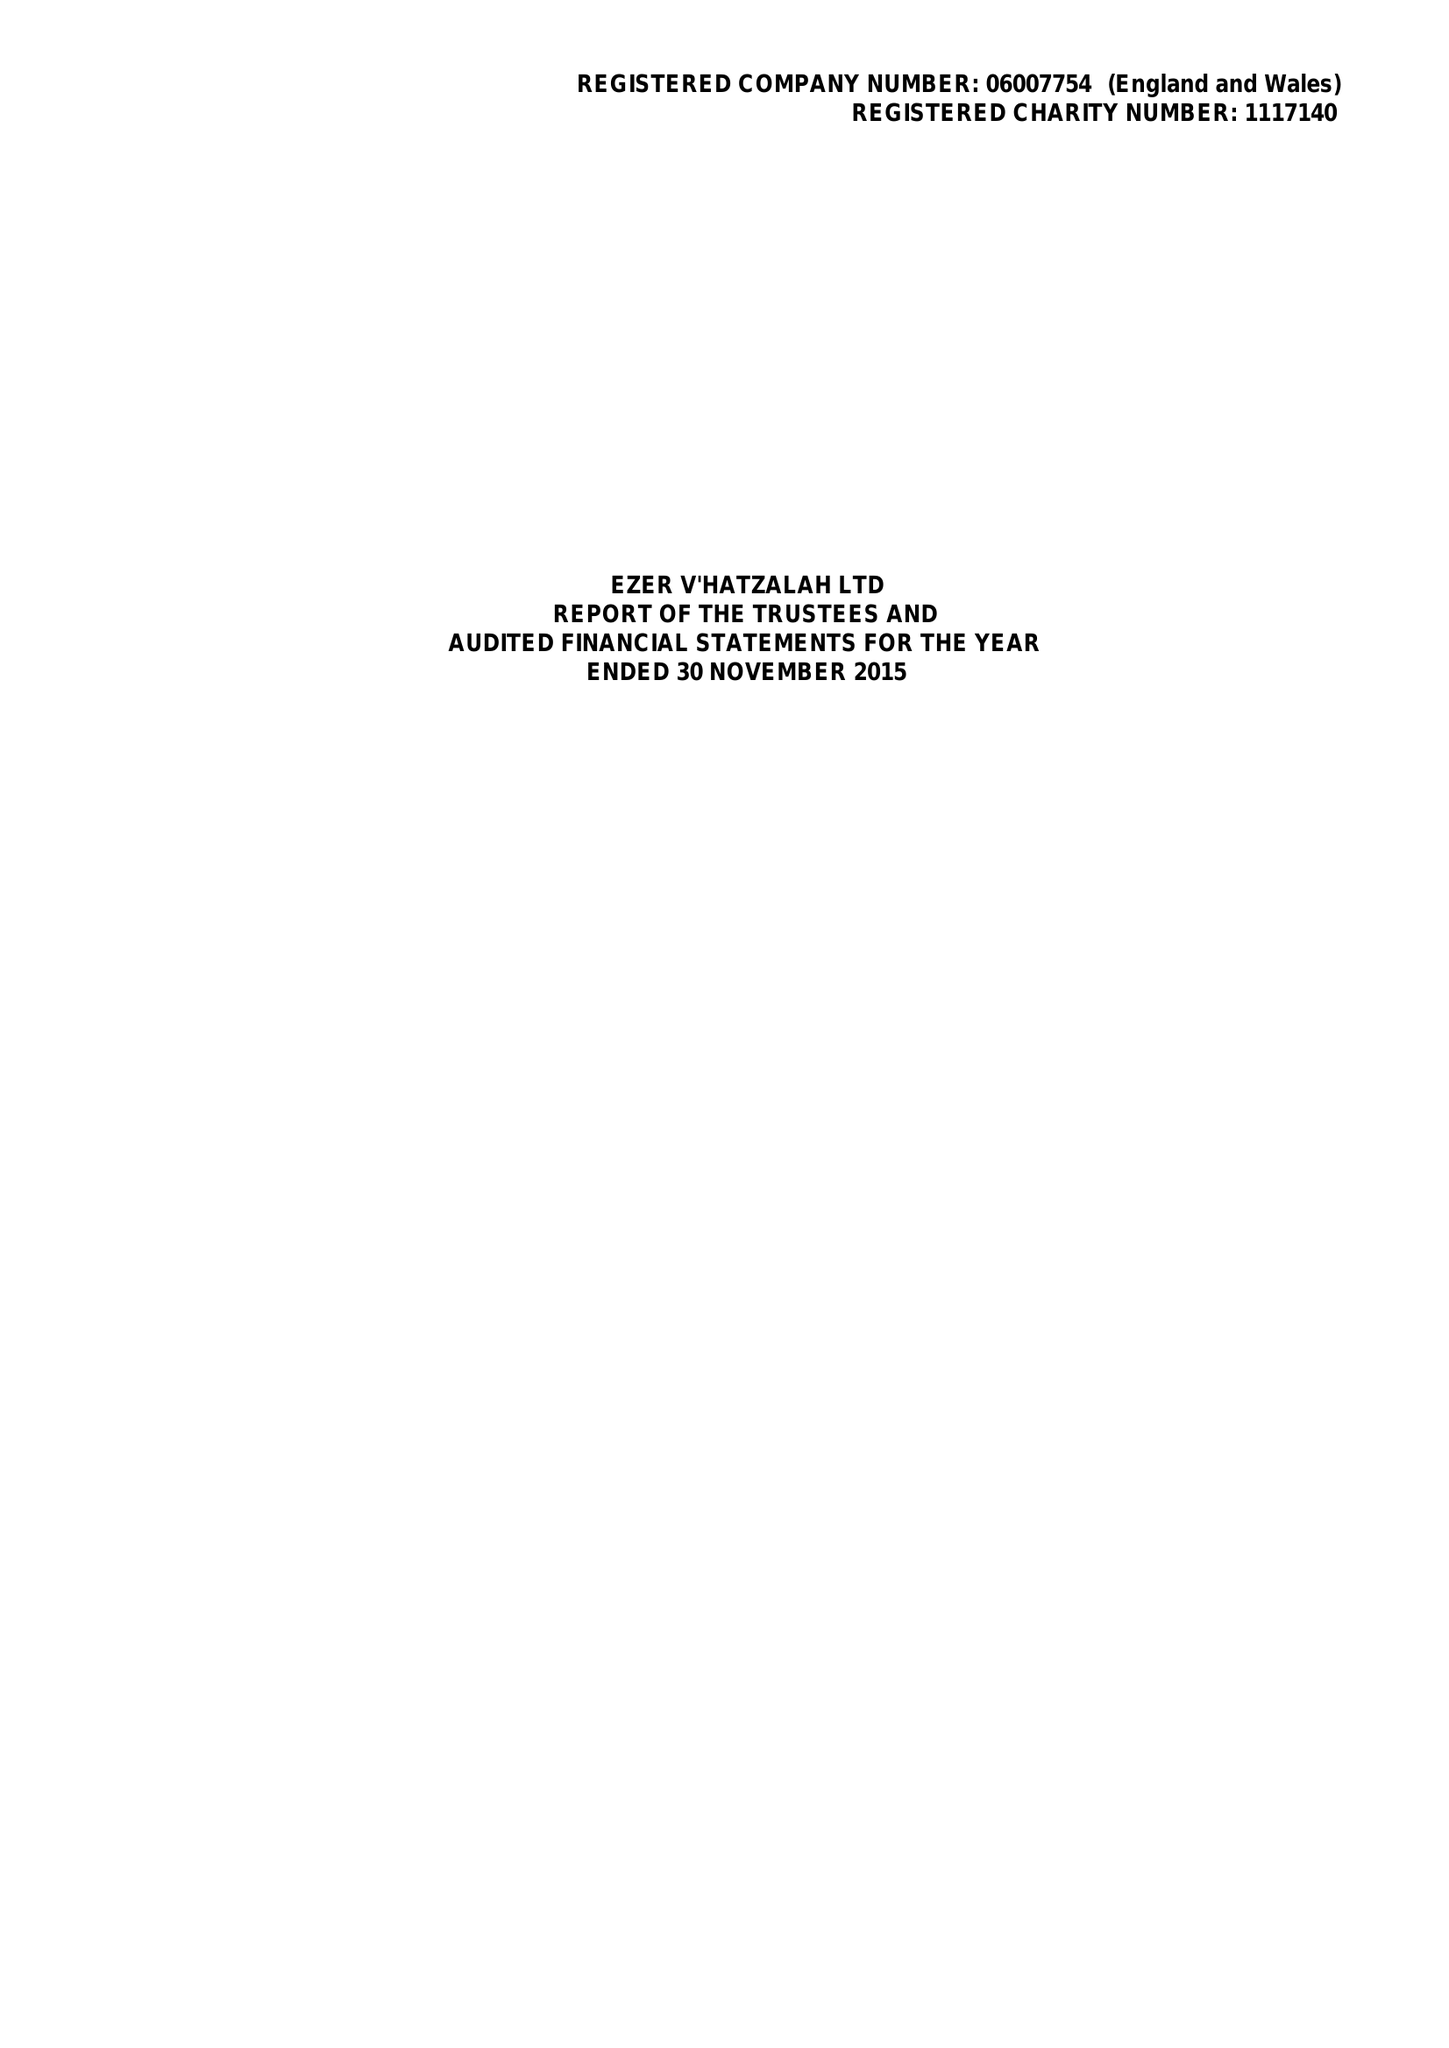What is the value for the address__postcode?
Answer the question using a single word or phrase. N16 5PZ 